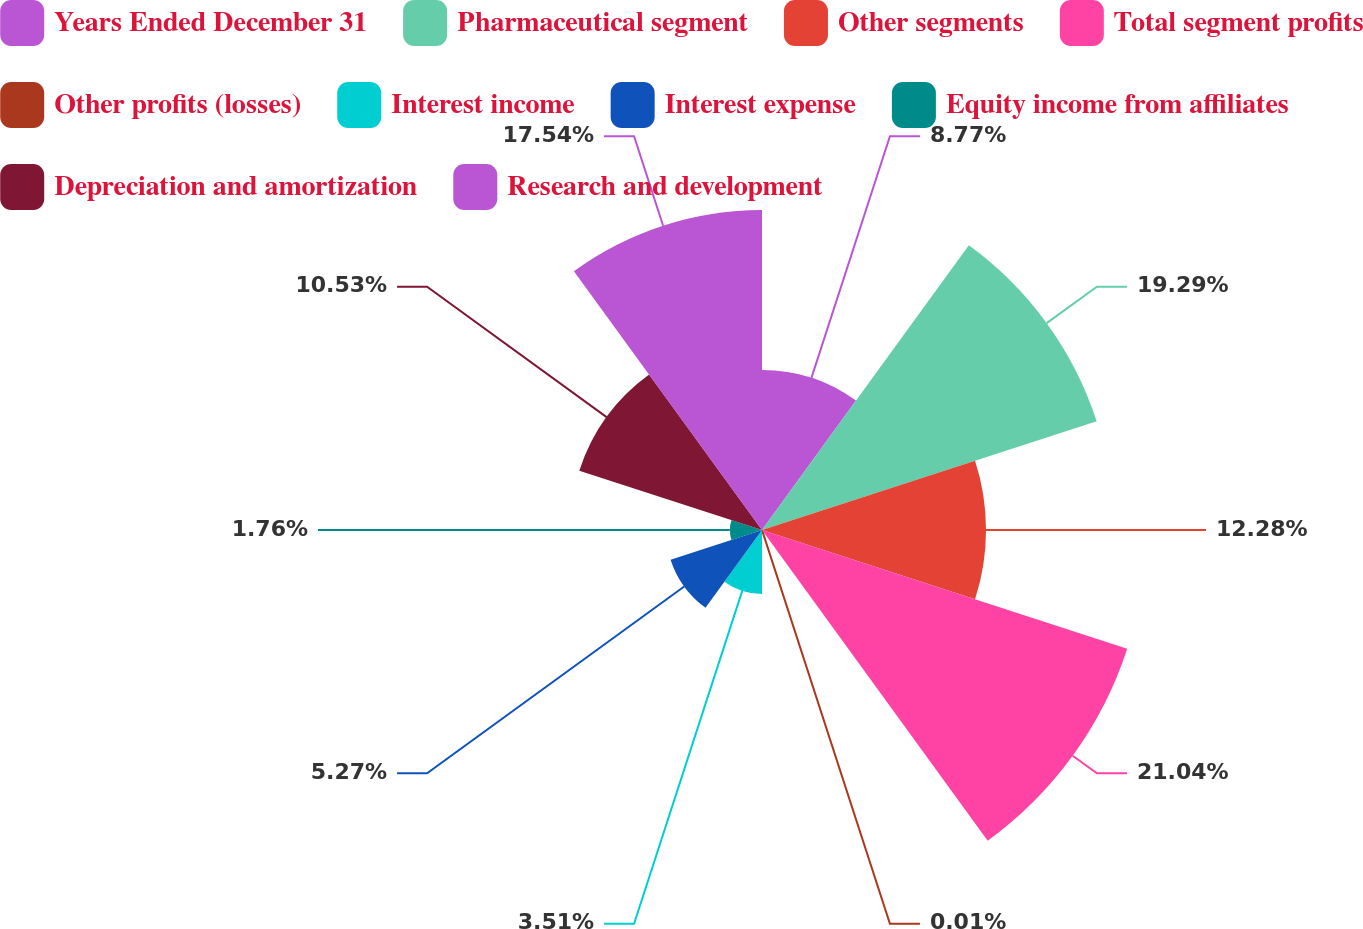<chart> <loc_0><loc_0><loc_500><loc_500><pie_chart><fcel>Years Ended December 31<fcel>Pharmaceutical segment<fcel>Other segments<fcel>Total segment profits<fcel>Other profits (losses)<fcel>Interest income<fcel>Interest expense<fcel>Equity income from affiliates<fcel>Depreciation and amortization<fcel>Research and development<nl><fcel>8.77%<fcel>19.29%<fcel>12.28%<fcel>21.05%<fcel>0.01%<fcel>3.51%<fcel>5.27%<fcel>1.76%<fcel>10.53%<fcel>17.54%<nl></chart> 